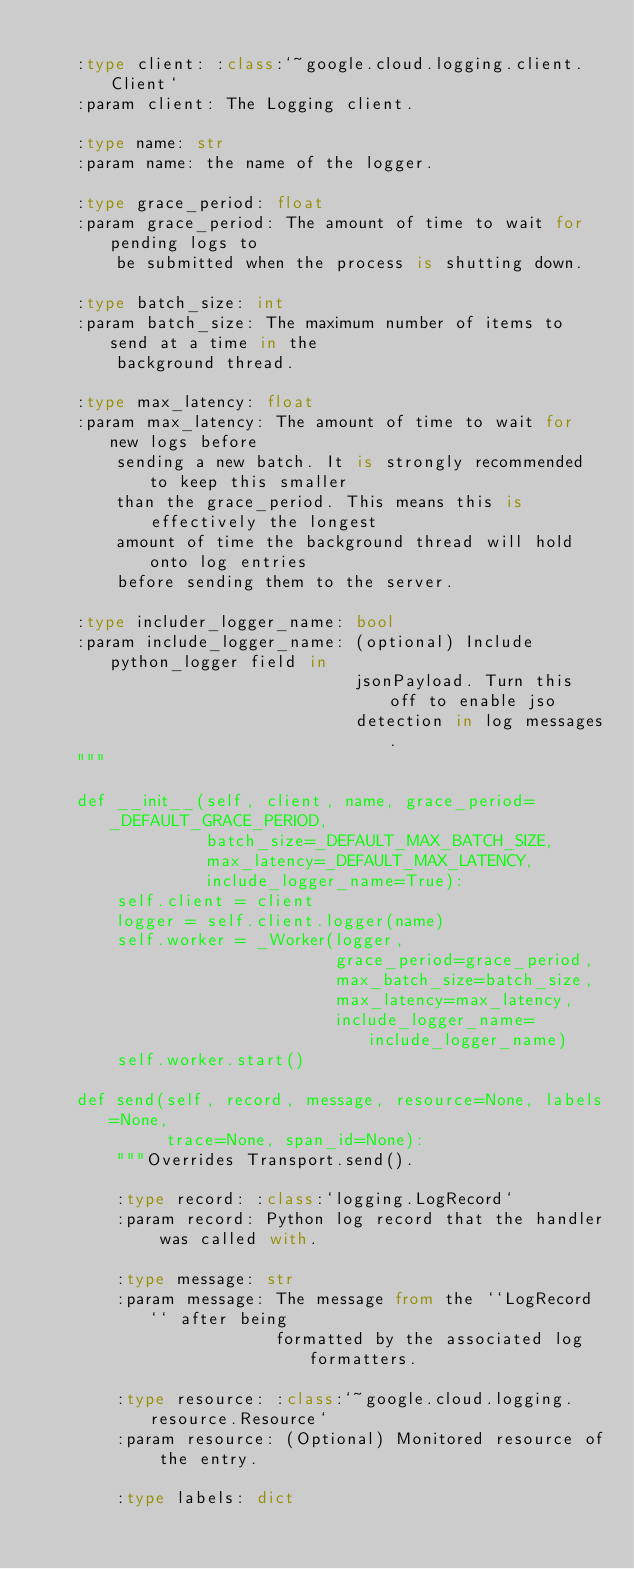Convert code to text. <code><loc_0><loc_0><loc_500><loc_500><_Python_>
    :type client: :class:`~google.cloud.logging.client.Client`
    :param client: The Logging client.

    :type name: str
    :param name: the name of the logger.

    :type grace_period: float
    :param grace_period: The amount of time to wait for pending logs to
        be submitted when the process is shutting down.

    :type batch_size: int
    :param batch_size: The maximum number of items to send at a time in the
        background thread.

    :type max_latency: float
    :param max_latency: The amount of time to wait for new logs before
        sending a new batch. It is strongly recommended to keep this smaller
        than the grace_period. This means this is effectively the longest
        amount of time the background thread will hold onto log entries
        before sending them to the server.

    :type includer_logger_name: bool
    :param include_logger_name: (optional) Include python_logger field in
                                jsonPayload. Turn this off to enable jso
                                detection in log messages.
    """

    def __init__(self, client, name, grace_period=_DEFAULT_GRACE_PERIOD,
                 batch_size=_DEFAULT_MAX_BATCH_SIZE,
                 max_latency=_DEFAULT_MAX_LATENCY,
                 include_logger_name=True):
        self.client = client
        logger = self.client.logger(name)
        self.worker = _Worker(logger,
                              grace_period=grace_period,
                              max_batch_size=batch_size,
                              max_latency=max_latency,
                              include_logger_name=include_logger_name)
        self.worker.start()

    def send(self, record, message, resource=None, labels=None,
             trace=None, span_id=None):
        """Overrides Transport.send().

        :type record: :class:`logging.LogRecord`
        :param record: Python log record that the handler was called with.

        :type message: str
        :param message: The message from the ``LogRecord`` after being
                        formatted by the associated log formatters.

        :type resource: :class:`~google.cloud.logging.resource.Resource`
        :param resource: (Optional) Monitored resource of the entry.

        :type labels: dict</code> 